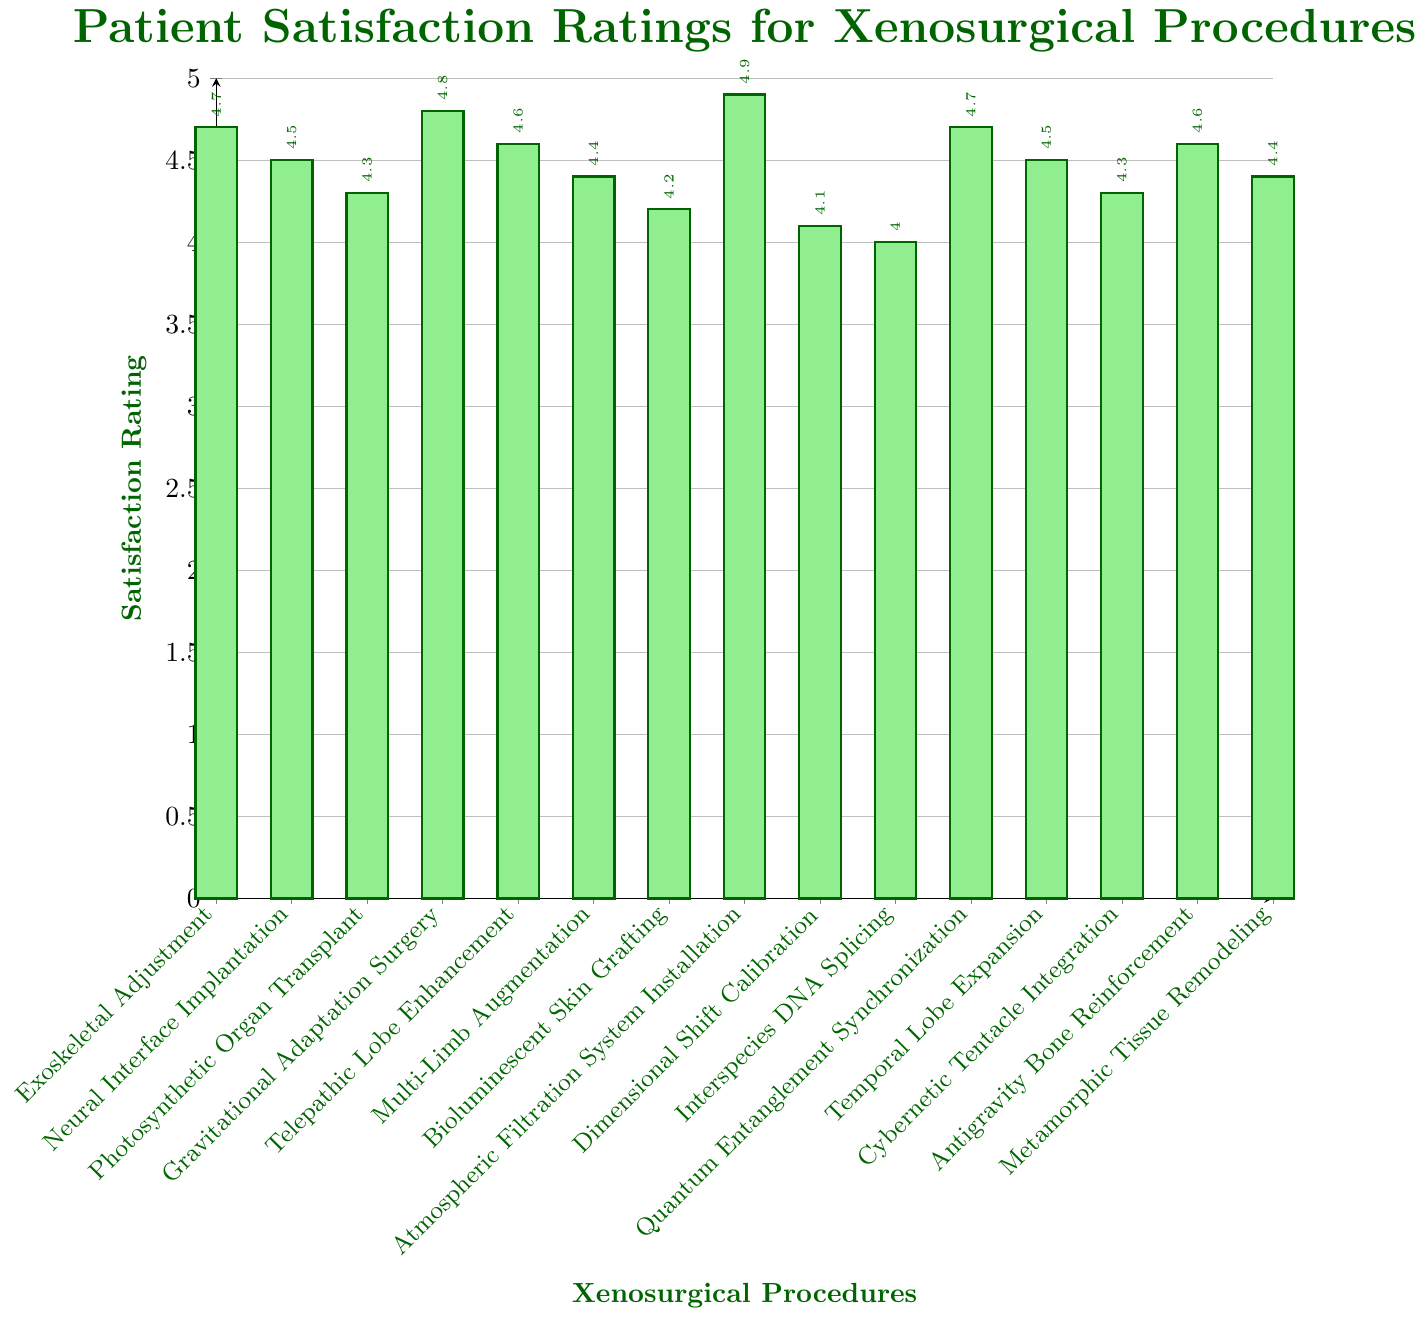Which procedure has the highest patient satisfaction rating? By visually inspecting the height of the bars, the tallest bar corresponds to Atmospheric Filtration System Installation, indicating it has the highest satisfaction rating.
Answer: Atmospheric Filtration System Installation What is the average satisfaction rating for all procedures? Add all the satisfaction ratings and then divide by the number of procedures: (4.7 + 4.5 + 4.3 + 4.8 + 4.6 + 4.4 + 4.2 + 4.9 + 4.1 + 4.0 + 4.7 + 4.5 + 4.3 + 4.6 + 4.4) / 15 = 4.47
Answer: 4.47 How many procedures have a satisfaction rating of 4.6 or higher? The bars reaching or exceeding the 4.6 mark correspond to these procedures: Exoskeletal Adjustment (4.7), Neural Interface Implantation (4.5), Gravitational Adaptation Surgery (4.8), Telepathic Lobe Enhancement (4.6), Atmospheric Filtration System Installation (4.9), Quantum Entanglement Synchronization (4.7), and Antigravity Bone Reinforcement (4.6). This totals 7 bars.
Answer: 7 Which procedures have the same satisfaction rating? By visually comparing the bar heights, Exoskeletal Adjustment and Quantum Entanglement Synchronization both have a rating of 4.7. Neural Interface Implantation and Temporal Lobe Expansion both have a rating of 4.5. Cybernetic Tentacle Integration and Photosynthetic Organ Transplant both have a rating of 4.3. Multi-Limb Augmentation and Metamorphic Tissue Remodeling both have a rating of 4.4. Antigravity Bone Reinforcement and Telepathic Lobe Enhancement both have a rating of 4.6.
Answer: Specific procedures listed in the explanation What is the difference between the highest and the lowest satisfaction ratings? The highest rating is 4.9 (Atmospheric Filtration System Installation) and the lowest is 4.0 (Interspecies DNA Splicing). The difference is 4.9 - 4.0 = 0.9
Answer: 0.9 Which procedure is ranked second highest in patient satisfaction? Visually inspecting the bar heights, the second tallest bar corresponds to Gravitational Adaptation Surgery, which has a satisfaction rating of 4.8, second only to Atmospheric Filtration System Installation.
Answer: Gravitational Adaptation Surgery How many procedures have a rating lower than 4.5? Bars below the 4.5 mark indicate the following procedures: Photosynthetic Organ Transplant (4.3), Multi-Limb Augmentation (4.4), Bioluminescent Skin Grafting (4.2), Dimensional Shift Calibration (4.1), Interspecies DNA Splicing (4.0), Cybernetic Tentacle Integration (4.3). This totals 6 bars.
Answer: 6 What is the median satisfaction rating for the procedures? First, list the ratings in ascending order: 4.0, 4.1, 4.2, 4.3, 4.3, 4.4, 4.4, 4.5, 4.5, 4.6, 4.6, 4.7, 4.7, 4.8, 4.9. The median is the middle value in this sorted list, which is the 8th value, or 4.5.
Answer: 4.5 